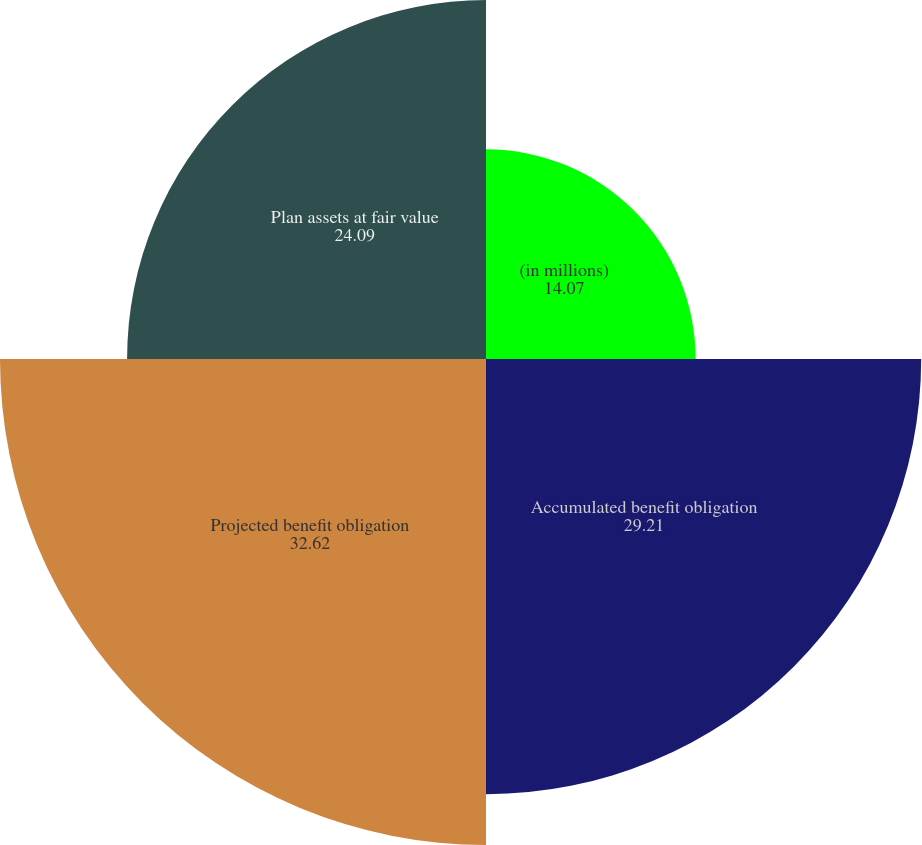Convert chart to OTSL. <chart><loc_0><loc_0><loc_500><loc_500><pie_chart><fcel>(in millions)<fcel>Accumulated benefit obligation<fcel>Projected benefit obligation<fcel>Plan assets at fair value<nl><fcel>14.07%<fcel>29.21%<fcel>32.62%<fcel>24.09%<nl></chart> 